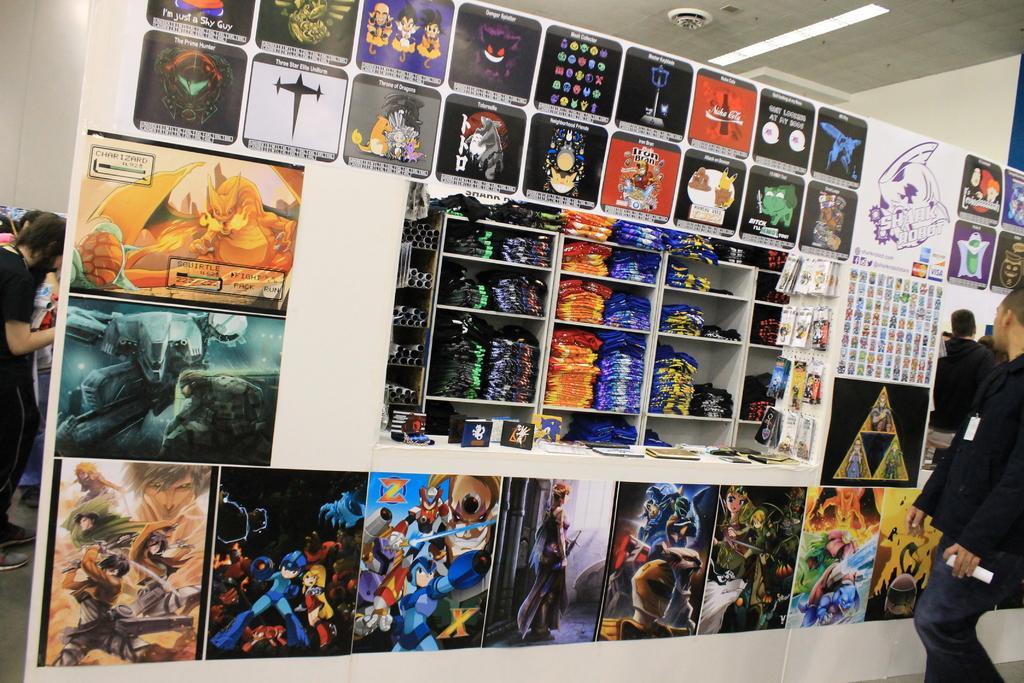Please provide a concise description of this image. In this image we can see the persons standing on the floor and holding paper. In front of the person we can see the board with images and there are racks, in that there are clothes and there are packets, boards and few objects. 